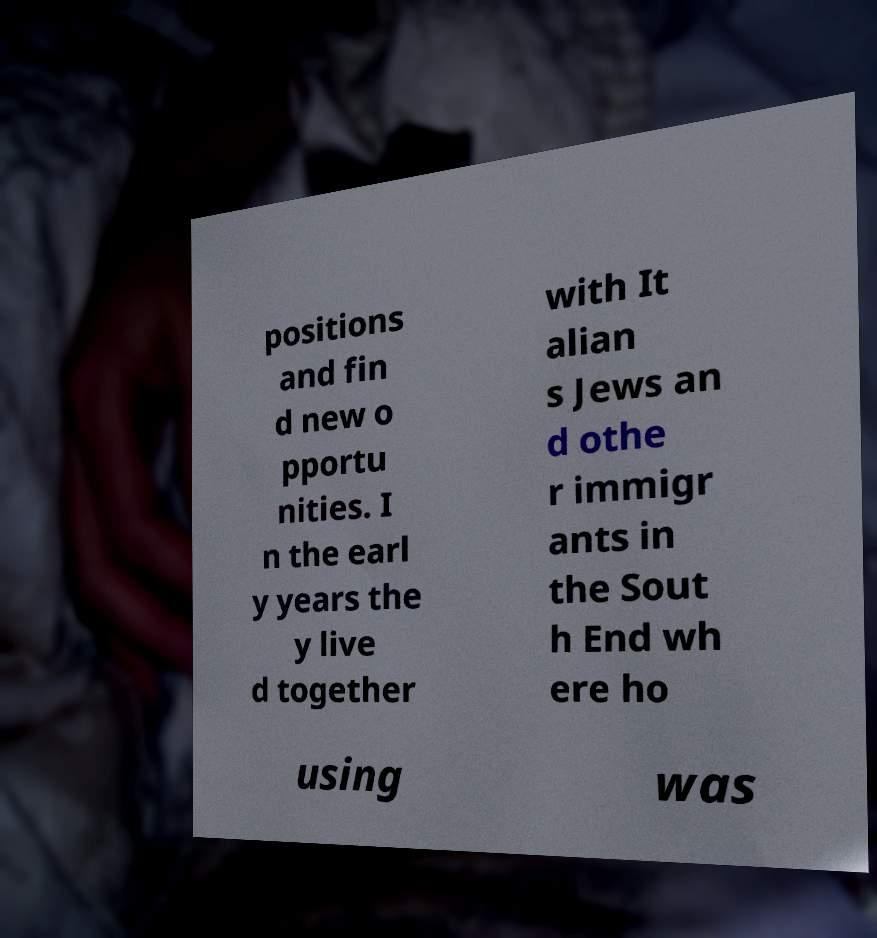For documentation purposes, I need the text within this image transcribed. Could you provide that? positions and fin d new o pportu nities. I n the earl y years the y live d together with It alian s Jews an d othe r immigr ants in the Sout h End wh ere ho using was 